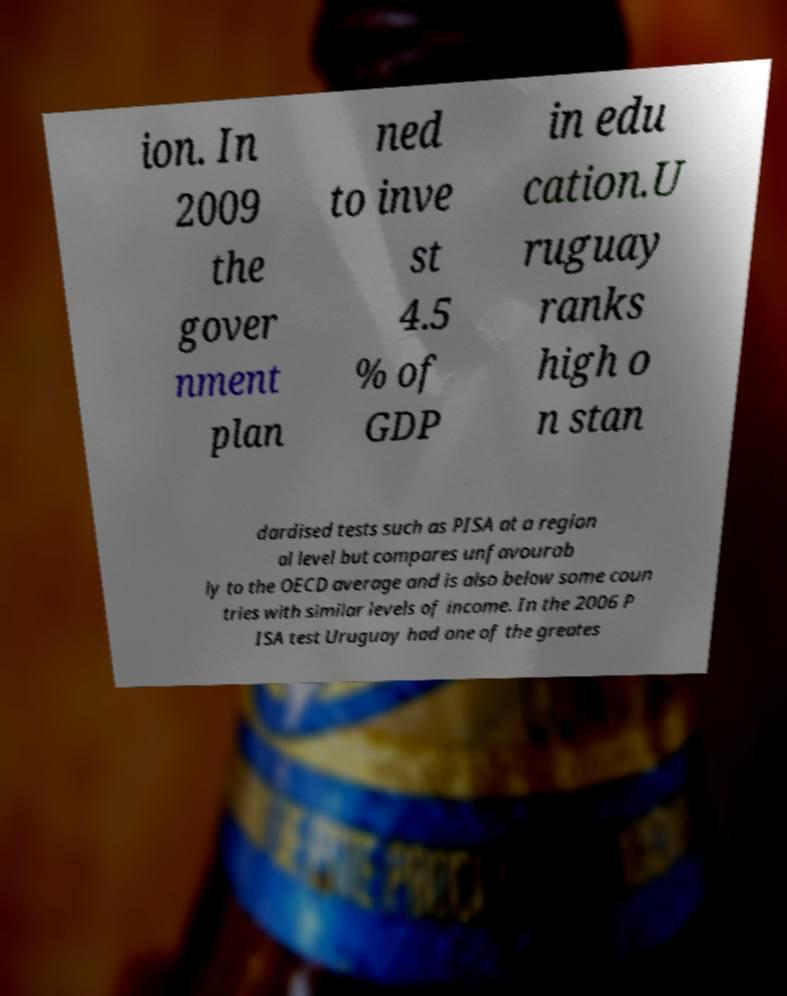Please read and relay the text visible in this image. What does it say? ion. In 2009 the gover nment plan ned to inve st 4.5 % of GDP in edu cation.U ruguay ranks high o n stan dardised tests such as PISA at a region al level but compares unfavourab ly to the OECD average and is also below some coun tries with similar levels of income. In the 2006 P ISA test Uruguay had one of the greates 